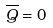Convert formula to latex. <formula><loc_0><loc_0><loc_500><loc_500>\overline { Q } = 0</formula> 